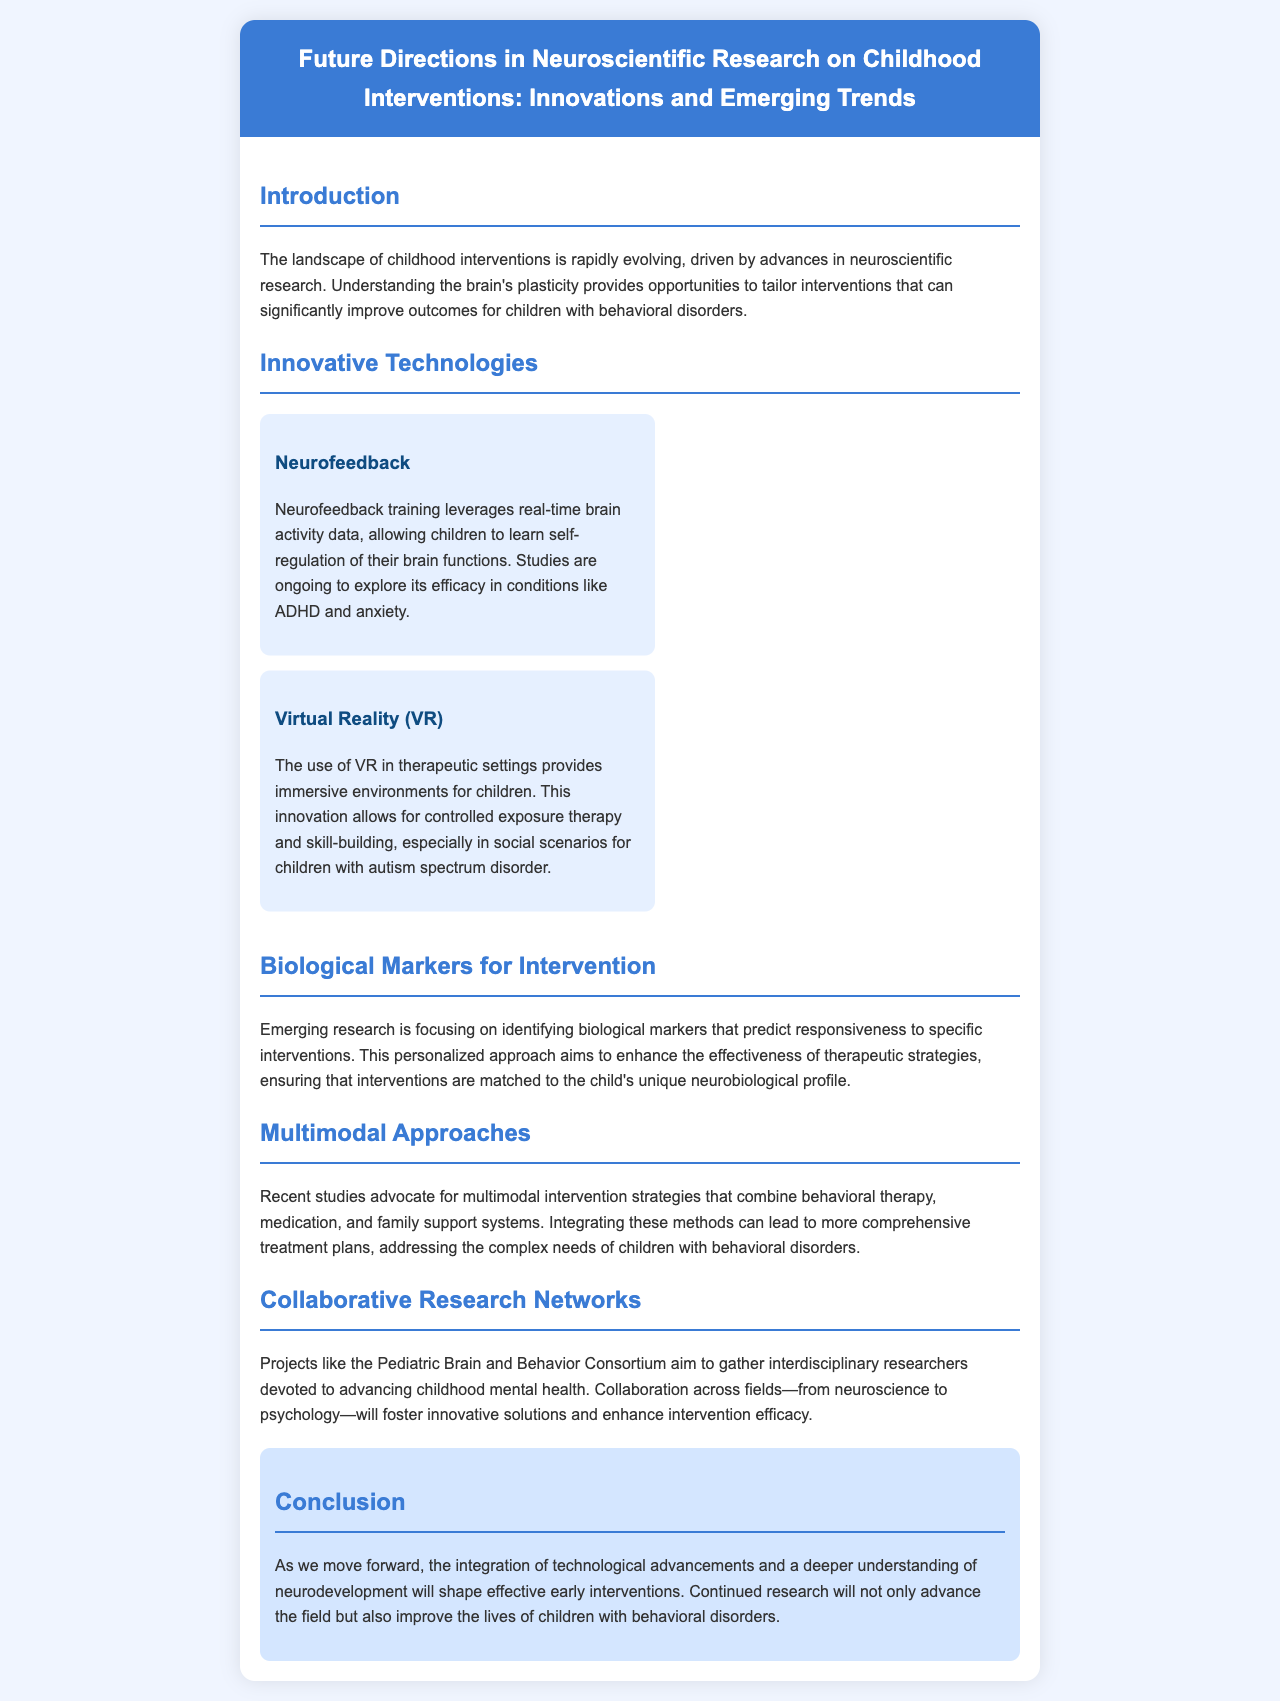what is the main focus of the brochure? The brochure discusses the future directions in neuroscientific research on childhood interventions.
Answer: future directions in neuroscientific research on childhood interventions what innovative technology is associated with self-regulation? The technology that allows children to learn self-regulation of their brain functions is Neurofeedback.
Answer: Neurofeedback what immersive technology is mentioned for therapeutic environments? The brochure mentions Virtual Reality (VR) as an innovative technology for therapeutic settings.
Answer: Virtual Reality (VR) which project aims to gather interdisciplinary researchers? The Pediatric Brain and Behavior Consortium is mentioned as a project that aims to gather interdisciplinary researchers.
Answer: Pediatric Brain and Behavior Consortium what is a key strategy in multimodal approaches? The document emphasizes the combination of behavioral therapy, medication, and family support systems as a key strategy.
Answer: combination of behavioral therapy, medication, and family support systems what does emerging research focus on in terms of interventions? Emerging research is focusing on identifying biological markers that predict responsiveness to specific interventions.
Answer: identifying biological markers what outcome does the brochure suggest will result from continued research? The brochure suggests that continued research will improve the lives of children with behavioral disorders.
Answer: improve the lives of children with behavioral disorders how does the introduction describe the landscape of childhood interventions? The introduction describes the landscape as rapidly evolving due to advances in neuroscientific research.
Answer: rapidly evolving due to advances in neuroscientific research what aspect of children's profiles is important for personalized approaches? The document highlights the importance of each child's unique neurobiological profile for personalized approaches.
Answer: unique neurobiological profile 